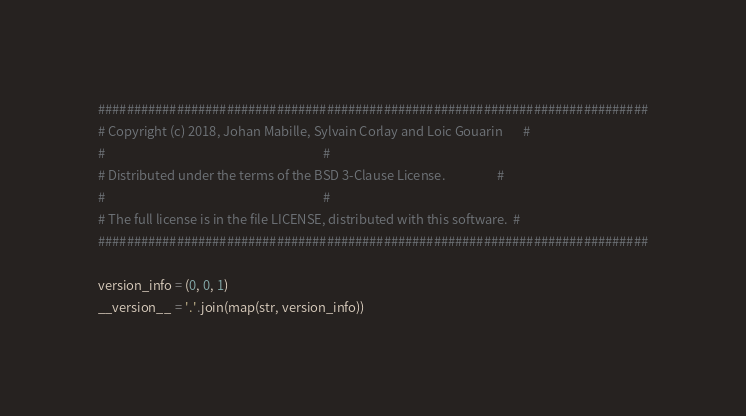Convert code to text. <code><loc_0><loc_0><loc_500><loc_500><_Python_>#############################################################################
# Copyright (c) 2018, Johan Mabille, Sylvain Corlay and Loic Gouarin       #
#                                                                           #
# Distributed under the terms of the BSD 3-Clause License.                  #
#                                                                           #
# The full license is in the file LICENSE, distributed with this software.  #
#############################################################################

version_info = (0, 0, 1)
__version__ = '.'.join(map(str, version_info))
</code> 